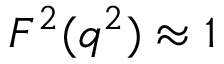Convert formula to latex. <formula><loc_0><loc_0><loc_500><loc_500>F ^ { 2 } ( q ^ { 2 } ) \approx 1</formula> 